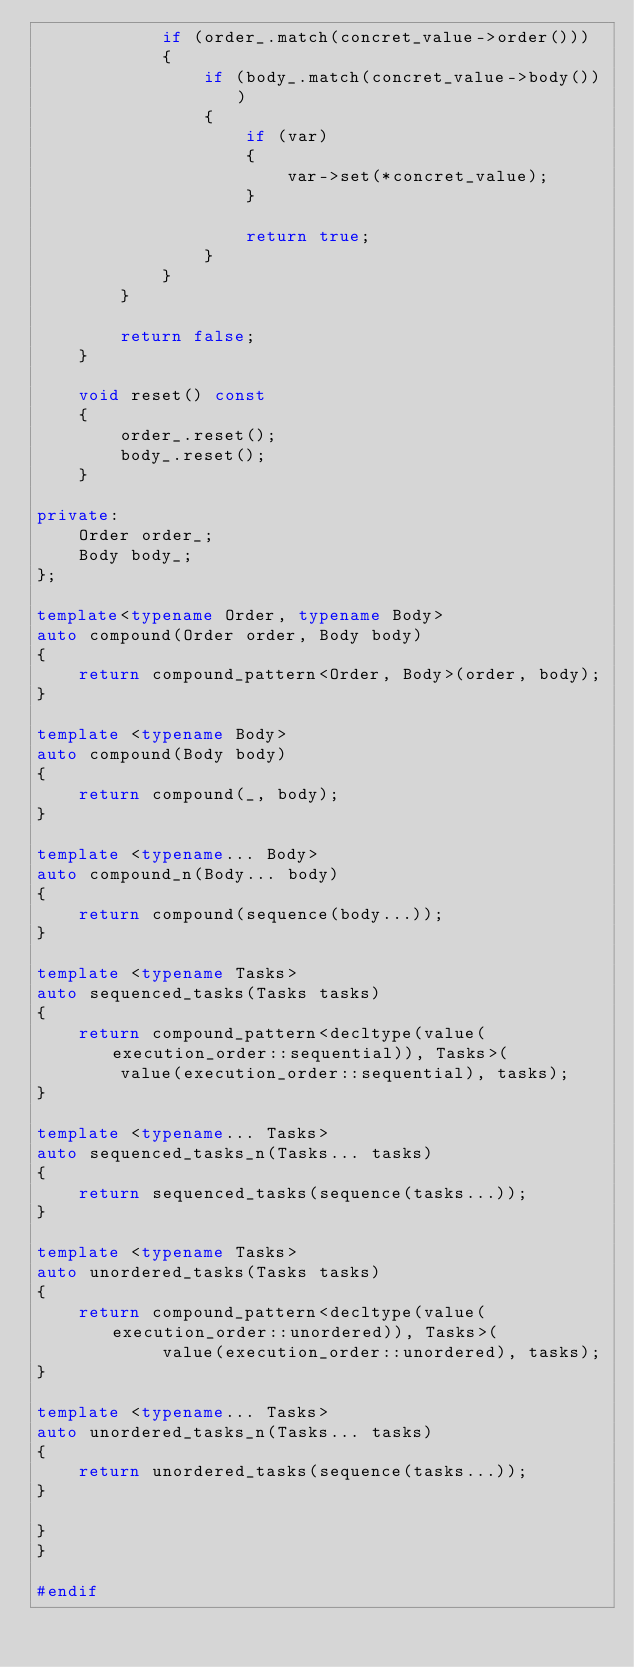<code> <loc_0><loc_0><loc_500><loc_500><_C++_>            if (order_.match(concret_value->order()))
            {
                if (body_.match(concret_value->body()))
                {
                    if (var)
                    {
                        var->set(*concret_value);
                    }

                    return true;
                }
            }
        }

        return false;
    }

    void reset() const
    {
        order_.reset();
        body_.reset();
    }

private:
    Order order_;
    Body body_;
};

template<typename Order, typename Body>
auto compound(Order order, Body body)
{
    return compound_pattern<Order, Body>(order, body);
}

template <typename Body>
auto compound(Body body)
{
    return compound(_, body);
}

template <typename... Body>
auto compound_n(Body... body)
{
    return compound(sequence(body...));
}

template <typename Tasks>
auto sequenced_tasks(Tasks tasks)
{
    return compound_pattern<decltype(value(execution_order::sequential)), Tasks>(
        value(execution_order::sequential), tasks);
}

template <typename... Tasks>
auto sequenced_tasks_n(Tasks... tasks)
{
    return sequenced_tasks(sequence(tasks...));
}

template <typename Tasks>
auto unordered_tasks(Tasks tasks)
{
    return compound_pattern<decltype(value(execution_order::unordered)), Tasks>(
            value(execution_order::unordered), tasks);
}

template <typename... Tasks>
auto unordered_tasks_n(Tasks... tasks)
{
    return unordered_tasks(sequence(tasks...));
}

}
}

#endif</code> 